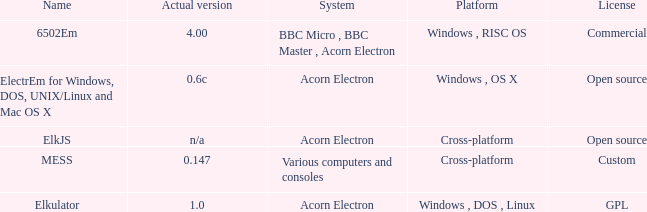What is the system called that is named ELKJS? Acorn Electron. 